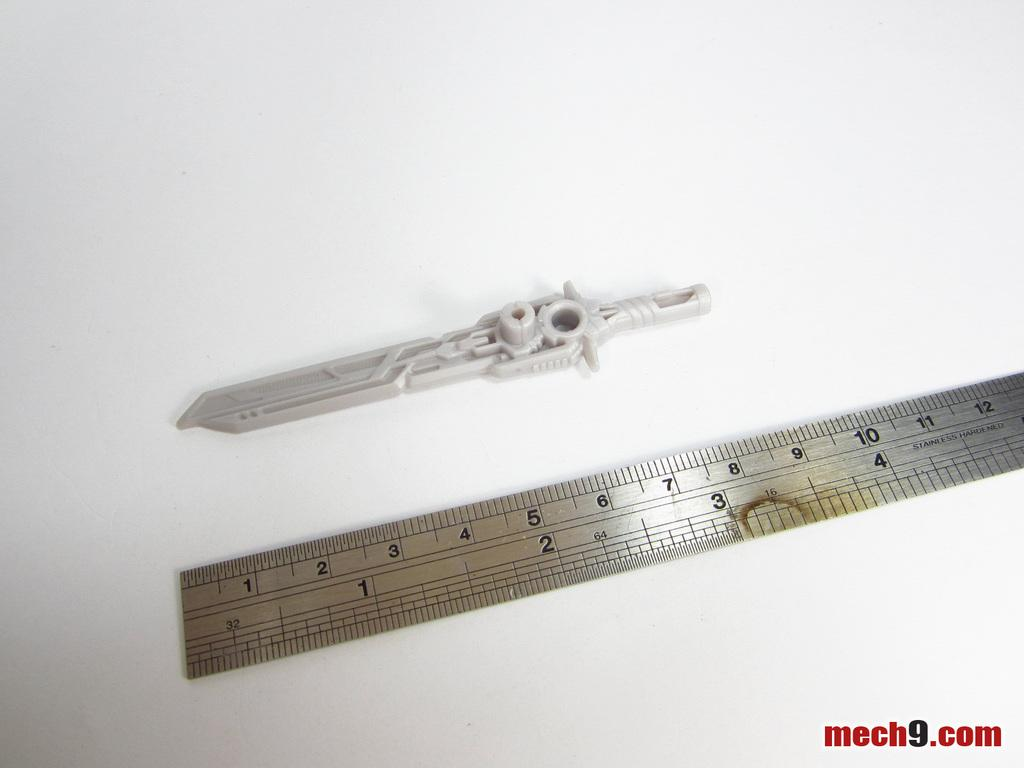<image>
Create a compact narrative representing the image presented. A plastic sword on a white background measuring three inches on a ruler below it. 